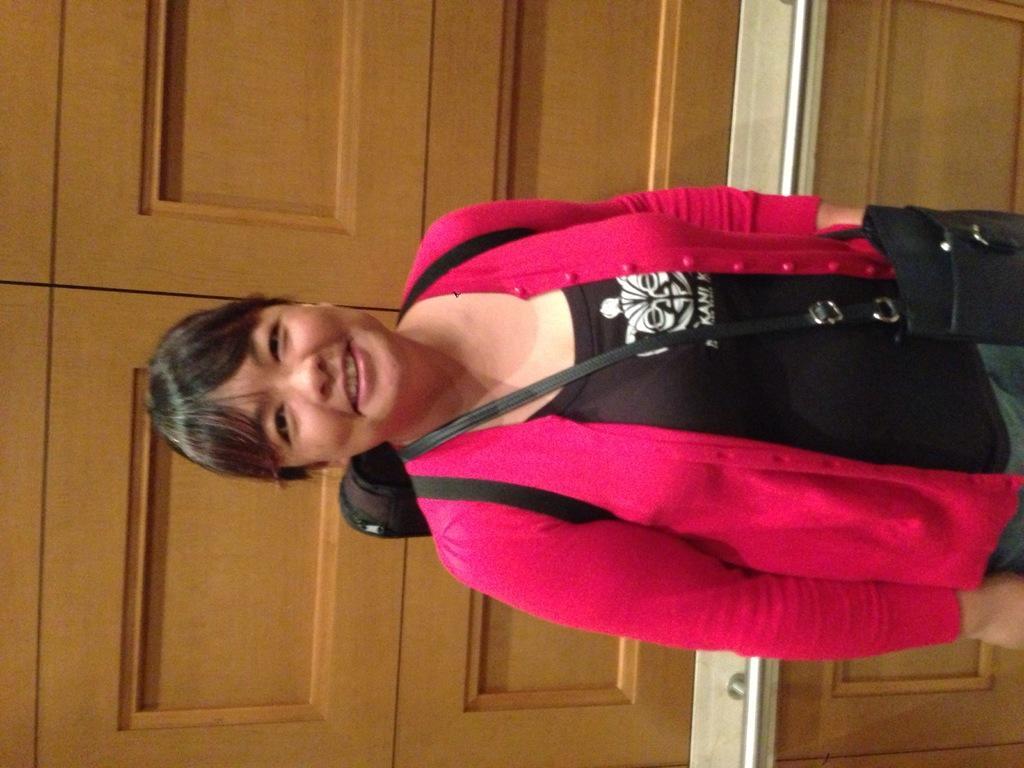In one or two sentences, can you explain what this image depicts? In this image I can see in the middle a woman is standing, she wore black color top, pink color sweater and smiling. Behind her there are doors. 